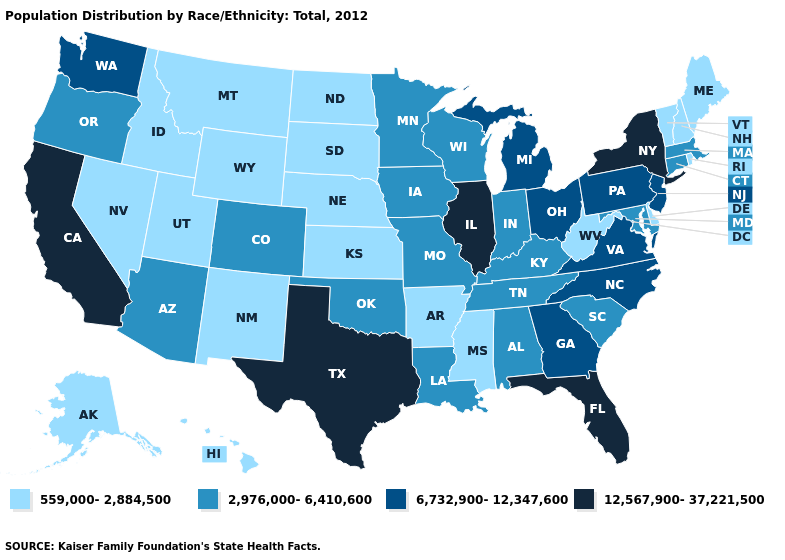What is the value of West Virginia?
Write a very short answer. 559,000-2,884,500. What is the value of Georgia?
Give a very brief answer. 6,732,900-12,347,600. Does Indiana have the highest value in the MidWest?
Be succinct. No. What is the value of New York?
Give a very brief answer. 12,567,900-37,221,500. Name the states that have a value in the range 559,000-2,884,500?
Answer briefly. Alaska, Arkansas, Delaware, Hawaii, Idaho, Kansas, Maine, Mississippi, Montana, Nebraska, Nevada, New Hampshire, New Mexico, North Dakota, Rhode Island, South Dakota, Utah, Vermont, West Virginia, Wyoming. Name the states that have a value in the range 6,732,900-12,347,600?
Answer briefly. Georgia, Michigan, New Jersey, North Carolina, Ohio, Pennsylvania, Virginia, Washington. What is the value of Mississippi?
Answer briefly. 559,000-2,884,500. Which states have the highest value in the USA?
Keep it brief. California, Florida, Illinois, New York, Texas. Which states have the highest value in the USA?
Keep it brief. California, Florida, Illinois, New York, Texas. Name the states that have a value in the range 6,732,900-12,347,600?
Answer briefly. Georgia, Michigan, New Jersey, North Carolina, Ohio, Pennsylvania, Virginia, Washington. Does Nebraska have a lower value than Massachusetts?
Keep it brief. Yes. Among the states that border Arkansas , which have the lowest value?
Short answer required. Mississippi. Name the states that have a value in the range 6,732,900-12,347,600?
Concise answer only. Georgia, Michigan, New Jersey, North Carolina, Ohio, Pennsylvania, Virginia, Washington. Name the states that have a value in the range 559,000-2,884,500?
Short answer required. Alaska, Arkansas, Delaware, Hawaii, Idaho, Kansas, Maine, Mississippi, Montana, Nebraska, Nevada, New Hampshire, New Mexico, North Dakota, Rhode Island, South Dakota, Utah, Vermont, West Virginia, Wyoming. What is the value of New Hampshire?
Keep it brief. 559,000-2,884,500. 